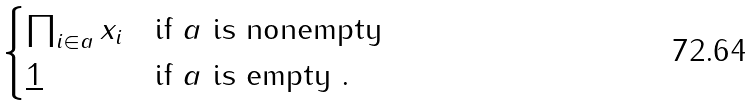<formula> <loc_0><loc_0><loc_500><loc_500>\begin{cases} \prod _ { i \in a } x _ { i } & \text {if $a$ is nonempty} \\ \underline { 1 } & \text {if $a$ is empty .} \end{cases}</formula> 